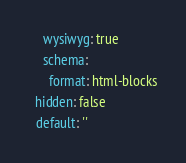<code> <loc_0><loc_0><loc_500><loc_500><_YAML_>    wysiwyg: true
    schema:
      format: html-blocks
  hidden: false
  default: ''
</code> 